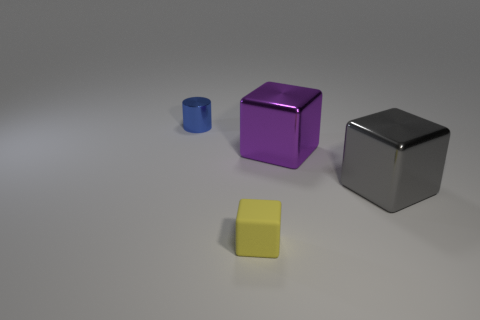Add 2 gray shiny things. How many objects exist? 6 Subtract all blocks. How many objects are left? 1 Add 1 blue metal things. How many blue metal things are left? 2 Add 1 large purple shiny cubes. How many large purple shiny cubes exist? 2 Subtract 1 gray blocks. How many objects are left? 3 Subtract all large gray matte cylinders. Subtract all gray shiny objects. How many objects are left? 3 